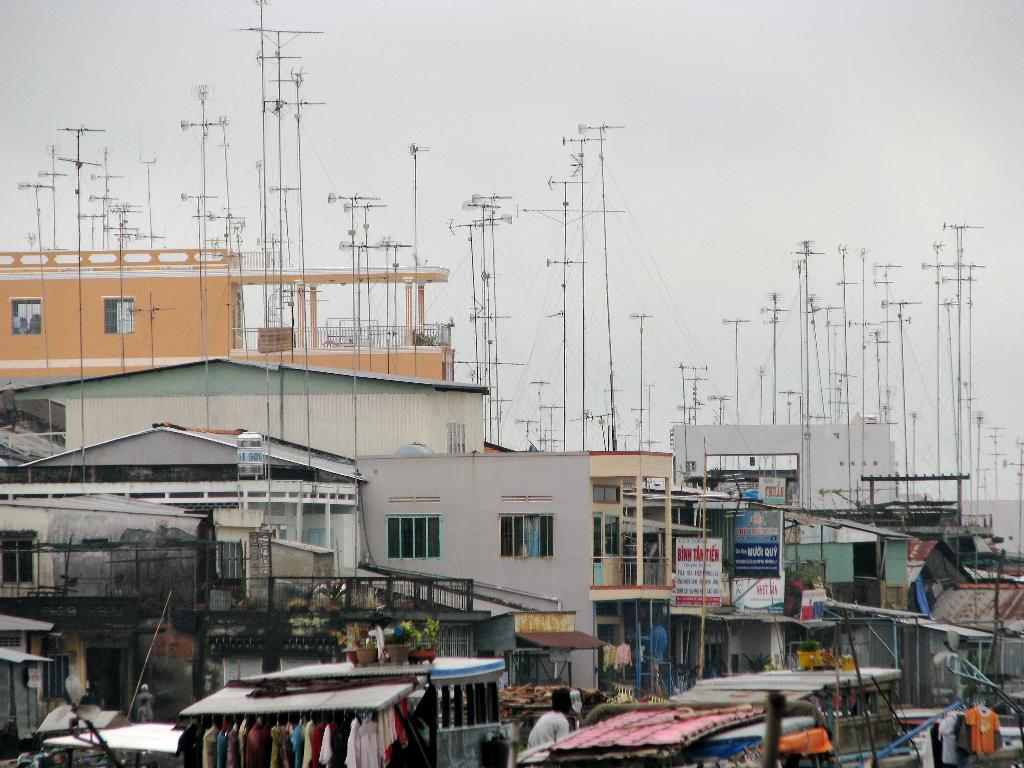What is the main subject of the image? Clothes are arranged in the image. What can be seen in the background of the image? There are buildings, poles, and hoardings in the background of the image. What is visible in the sky in the image? There are clouds in the sky in the image. What nation is represented by the flag on the hoarding in the image? There is no flag visible on the hoarding in the image. Who is the expert featured on the hoarding in the image? There is no expert featured on the hoarding in the image. 